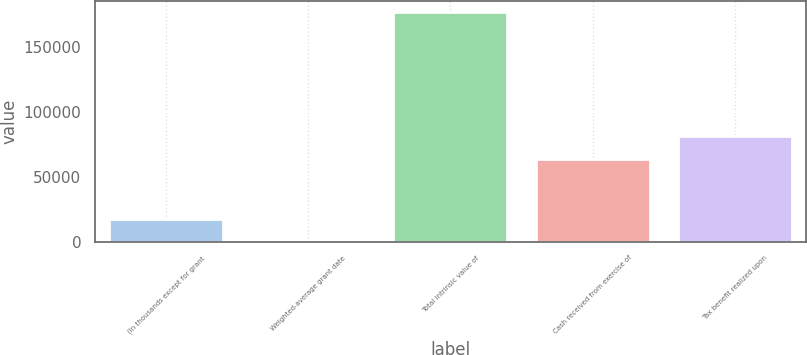<chart> <loc_0><loc_0><loc_500><loc_500><bar_chart><fcel>(In thousands except for grant<fcel>Weighted-average grant date<fcel>Total intrinsic value of<fcel>Cash received from exercise of<fcel>Tax benefit realized upon<nl><fcel>17754<fcel>18.31<fcel>177375<fcel>63794<fcel>81529.7<nl></chart> 